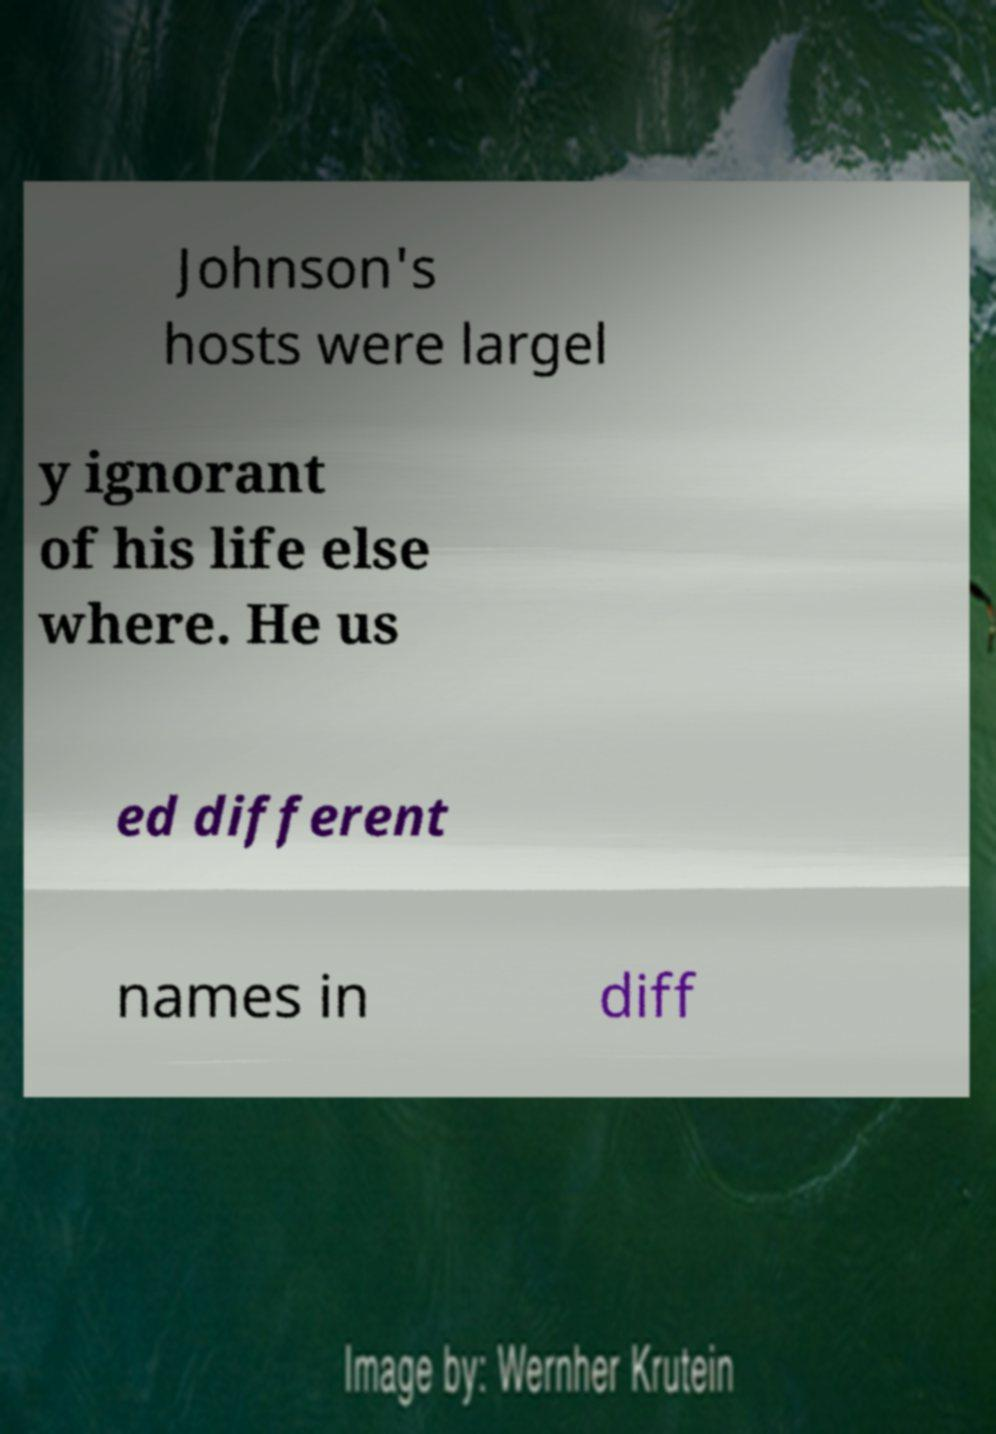Could you assist in decoding the text presented in this image and type it out clearly? Johnson's hosts were largel y ignorant of his life else where. He us ed different names in diff 